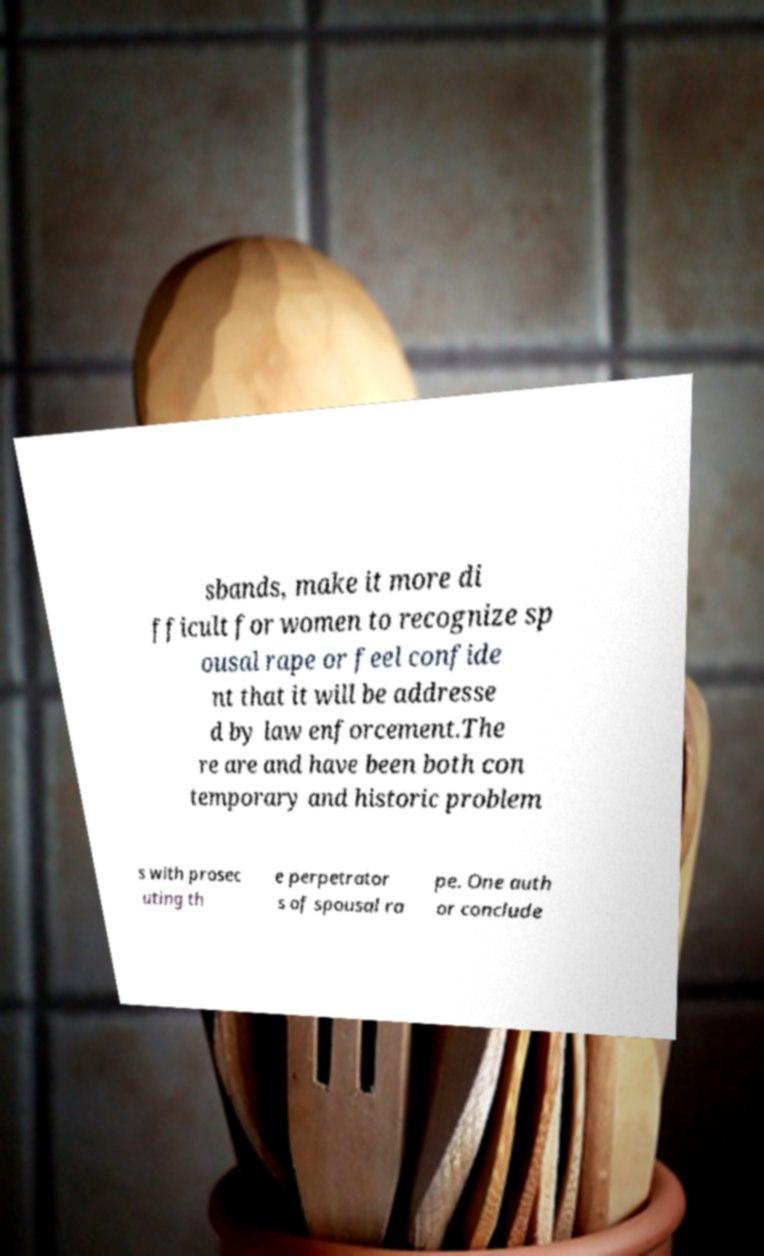I need the written content from this picture converted into text. Can you do that? sbands, make it more di fficult for women to recognize sp ousal rape or feel confide nt that it will be addresse d by law enforcement.The re are and have been both con temporary and historic problem s with prosec uting th e perpetrator s of spousal ra pe. One auth or conclude 